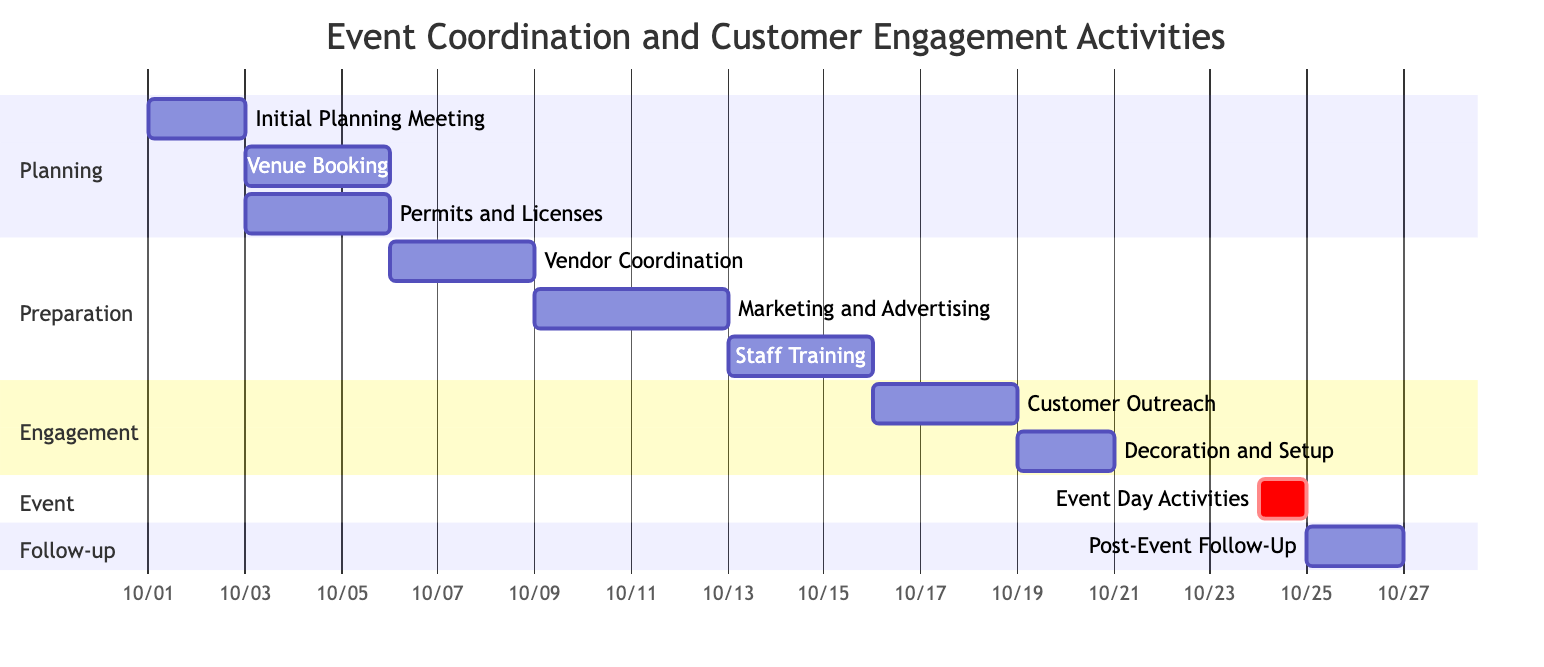What is the duration of the Event Day Activities? The Event Day Activities start on October 24, 2023, and end on the same day. Thus, the duration is 1 day.
Answer: 1 day How many activities are there in the Preparation section? In the Preparation section, there are three activities: Vendor Coordination, Marketing and Advertising, and Staff Training.
Answer: 3 Which activity follows Customer Outreach? Decoration and Setup follows Customer Outreach. The dependencies indicate that Decoration and Setup begins after Customer Outreach is completed.
Answer: Decoration and Setup What is the start date for Marketing and Advertising? According to the diagram, Marketing and Advertising starts on October 12, 2023, after the completion of Vendor Coordination.
Answer: October 12, 2023 What is the total duration of the Follow-up section? The Follow-up section includes Post-Event Follow-Up, which lasts for 2 days (from October 25 to October 26). Thus, the total duration is 2 days.
Answer: 2 days What activity has the longest duration in the diagram? The activity with the longest duration is Marketing and Advertising, lasting for 4 days (from October 12 to October 15).
Answer: Marketing and Advertising When does Staff Training begin? Staff Training begins on October 16, 2023, after Marketing and Advertising concludes on October 15, 2023.
Answer: October 16, 2023 How many days in total are allocated for planning activities? The planning activities include Initial Planning Meeting (2 days), Venue Booking (3 days), and Permits and Licenses (3 days), totaling 8 days.
Answer: 8 days Which activity is critically linked to Event Day Activities? Decoration and Setup is critically linked to Event Day Activities, as it must be completed before the event can occur.
Answer: Decoration and Setup 